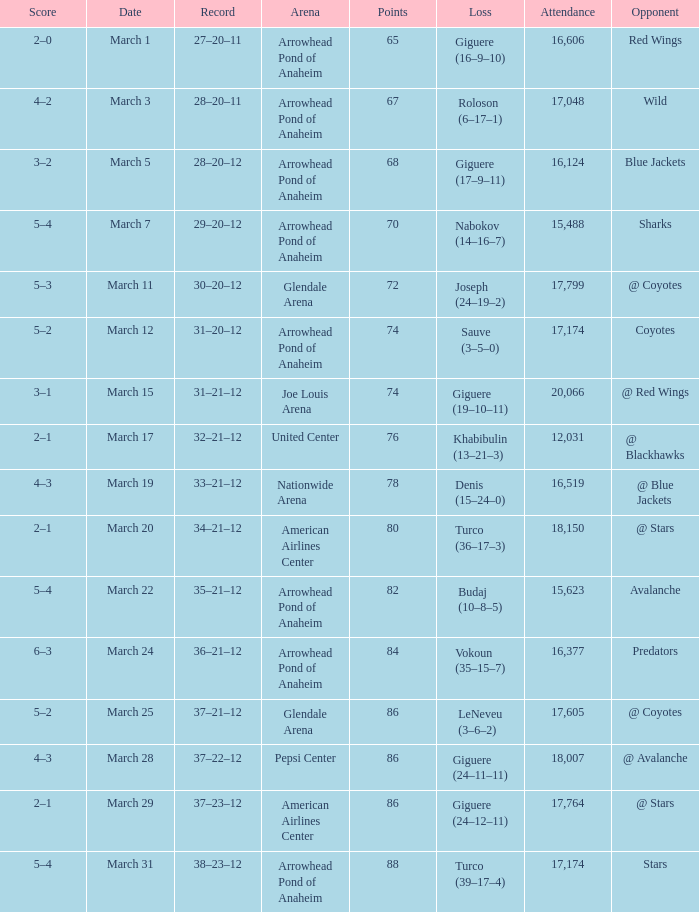What is the Attendance at Joe Louis Arena? 20066.0. Could you parse the entire table as a dict? {'header': ['Score', 'Date', 'Record', 'Arena', 'Points', 'Loss', 'Attendance', 'Opponent'], 'rows': [['2–0', 'March 1', '27–20–11', 'Arrowhead Pond of Anaheim', '65', 'Giguere (16–9–10)', '16,606', 'Red Wings'], ['4–2', 'March 3', '28–20–11', 'Arrowhead Pond of Anaheim', '67', 'Roloson (6–17–1)', '17,048', 'Wild'], ['3–2', 'March 5', '28–20–12', 'Arrowhead Pond of Anaheim', '68', 'Giguere (17–9–11)', '16,124', 'Blue Jackets'], ['5–4', 'March 7', '29–20–12', 'Arrowhead Pond of Anaheim', '70', 'Nabokov (14–16–7)', '15,488', 'Sharks'], ['5–3', 'March 11', '30–20–12', 'Glendale Arena', '72', 'Joseph (24–19–2)', '17,799', '@ Coyotes'], ['5–2', 'March 12', '31–20–12', 'Arrowhead Pond of Anaheim', '74', 'Sauve (3–5–0)', '17,174', 'Coyotes'], ['3–1', 'March 15', '31–21–12', 'Joe Louis Arena', '74', 'Giguere (19–10–11)', '20,066', '@ Red Wings'], ['2–1', 'March 17', '32–21–12', 'United Center', '76', 'Khabibulin (13–21–3)', '12,031', '@ Blackhawks'], ['4–3', 'March 19', '33–21–12', 'Nationwide Arena', '78', 'Denis (15–24–0)', '16,519', '@ Blue Jackets'], ['2–1', 'March 20', '34–21–12', 'American Airlines Center', '80', 'Turco (36–17–3)', '18,150', '@ Stars'], ['5–4', 'March 22', '35–21–12', 'Arrowhead Pond of Anaheim', '82', 'Budaj (10–8–5)', '15,623', 'Avalanche'], ['6–3', 'March 24', '36–21–12', 'Arrowhead Pond of Anaheim', '84', 'Vokoun (35–15–7)', '16,377', 'Predators'], ['5–2', 'March 25', '37–21–12', 'Glendale Arena', '86', 'LeNeveu (3–6–2)', '17,605', '@ Coyotes'], ['4–3', 'March 28', '37–22–12', 'Pepsi Center', '86', 'Giguere (24–11–11)', '18,007', '@ Avalanche'], ['2–1', 'March 29', '37–23–12', 'American Airlines Center', '86', 'Giguere (24–12–11)', '17,764', '@ Stars'], ['5–4', 'March 31', '38–23–12', 'Arrowhead Pond of Anaheim', '88', 'Turco (39–17–4)', '17,174', 'Stars']]} 